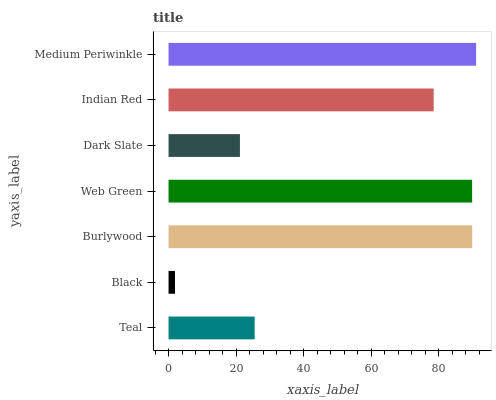Is Black the minimum?
Answer yes or no. Yes. Is Medium Periwinkle the maximum?
Answer yes or no. Yes. Is Burlywood the minimum?
Answer yes or no. No. Is Burlywood the maximum?
Answer yes or no. No. Is Burlywood greater than Black?
Answer yes or no. Yes. Is Black less than Burlywood?
Answer yes or no. Yes. Is Black greater than Burlywood?
Answer yes or no. No. Is Burlywood less than Black?
Answer yes or no. No. Is Indian Red the high median?
Answer yes or no. Yes. Is Indian Red the low median?
Answer yes or no. Yes. Is Teal the high median?
Answer yes or no. No. Is Dark Slate the low median?
Answer yes or no. No. 